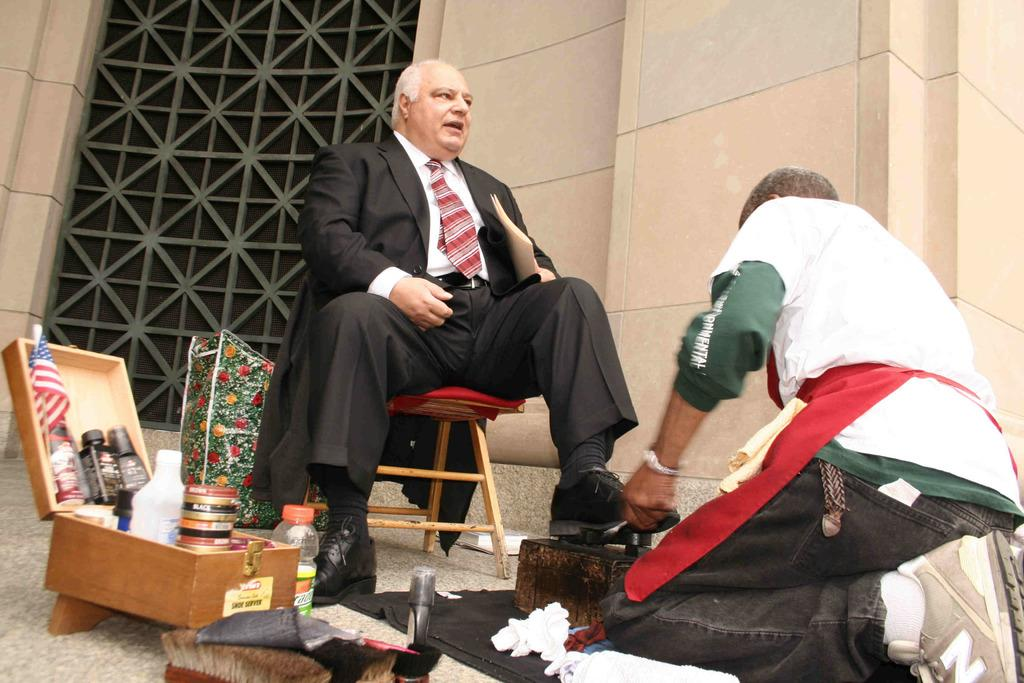How many people are present in the image? There are two people in the image. What can be seen on the left side of the image? There is a box with objects on the left side of the image. What is the man in the image doing? A man is sitting on a table in the image. What type of parcel is the rat holding in the image? There is no rat or parcel present in the image. 